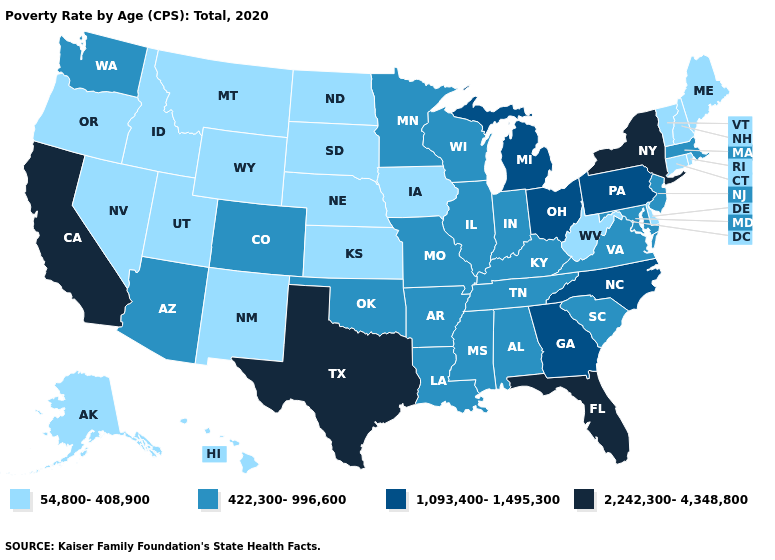Among the states that border Maryland , does Pennsylvania have the highest value?
Give a very brief answer. Yes. Does Washington have the same value as Arkansas?
Quick response, please. Yes. Name the states that have a value in the range 2,242,300-4,348,800?
Quick response, please. California, Florida, New York, Texas. Name the states that have a value in the range 1,093,400-1,495,300?
Answer briefly. Georgia, Michigan, North Carolina, Ohio, Pennsylvania. What is the lowest value in the West?
Quick response, please. 54,800-408,900. Does Arizona have the highest value in the USA?
Concise answer only. No. How many symbols are there in the legend?
Give a very brief answer. 4. Does South Dakota have the lowest value in the MidWest?
Write a very short answer. Yes. What is the highest value in the USA?
Be succinct. 2,242,300-4,348,800. Which states have the lowest value in the South?
Short answer required. Delaware, West Virginia. What is the value of New Hampshire?
Keep it brief. 54,800-408,900. What is the lowest value in the West?
Write a very short answer. 54,800-408,900. What is the highest value in states that border Illinois?
Be succinct. 422,300-996,600. What is the highest value in the South ?
Give a very brief answer. 2,242,300-4,348,800. 